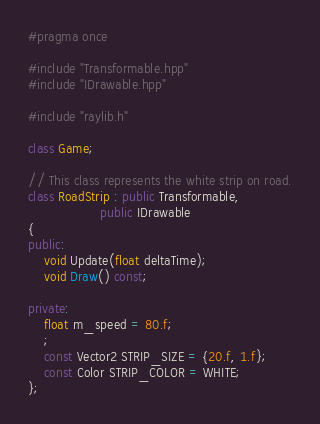Convert code to text. <code><loc_0><loc_0><loc_500><loc_500><_C++_>#pragma once

#include "Transformable.hpp"
#include "IDrawable.hpp"

#include "raylib.h"

class Game;

// This class represents the white strip on road.
class RoadStrip : public Transformable,
                  public IDrawable
{
public:
    void Update(float deltaTime);
    void Draw() const;

private:
    float m_speed = 80.f;
    ;
    const Vector2 STRIP_SIZE = {20.f, 1.f};
    const Color STRIP_COLOR = WHITE;
};
</code> 